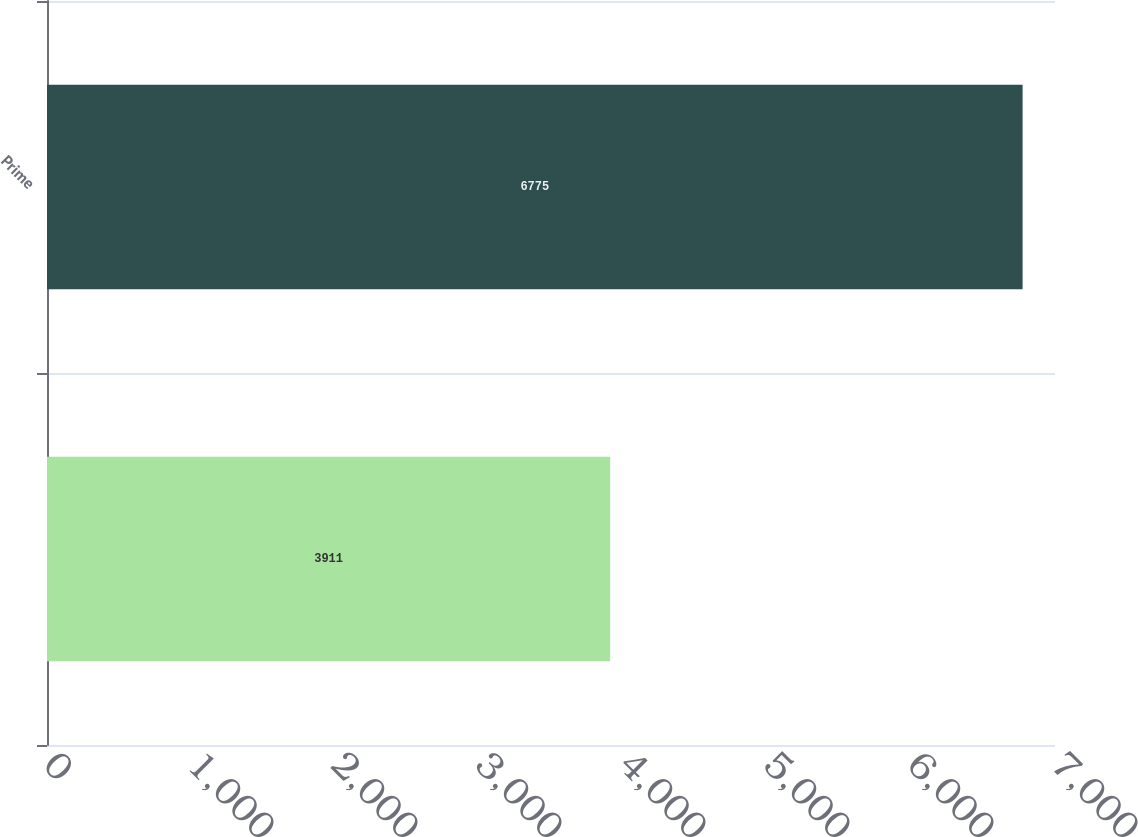Convert chart to OTSL. <chart><loc_0><loc_0><loc_500><loc_500><bar_chart><ecel><fcel>Prime<nl><fcel>3911<fcel>6775<nl></chart> 